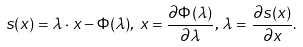Convert formula to latex. <formula><loc_0><loc_0><loc_500><loc_500>s ( x ) = \lambda \cdot x - \Phi ( \lambda ) , \, x = \frac { \partial \Phi ( \lambda ) } { \partial \lambda } , \, \lambda = \frac { \partial s ( x ) } { \partial x } .</formula> 